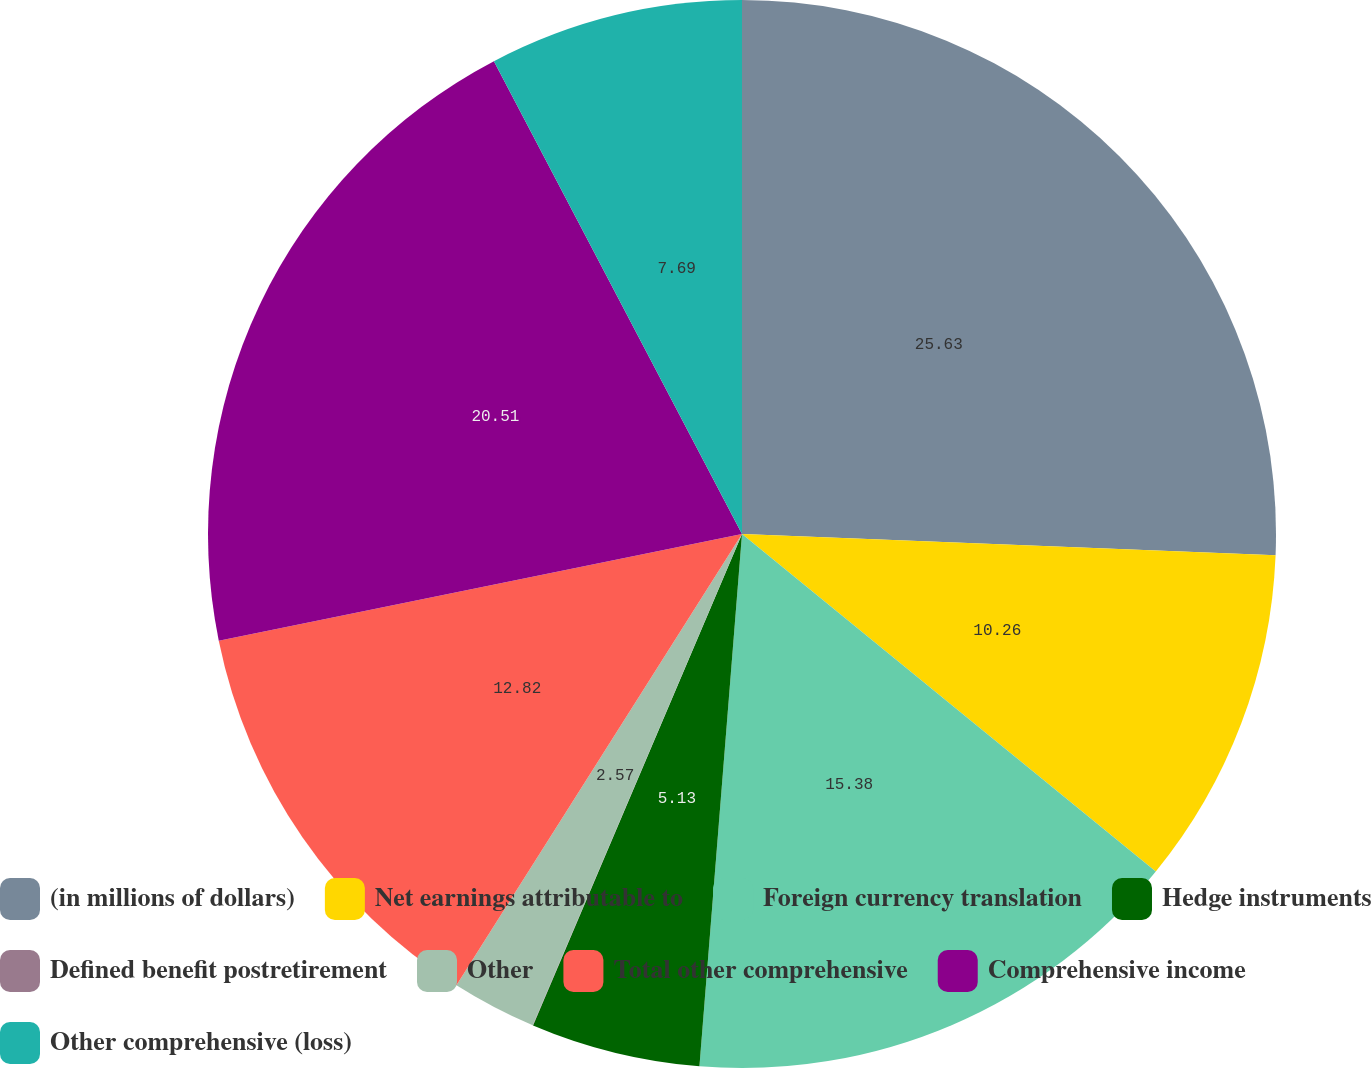Convert chart. <chart><loc_0><loc_0><loc_500><loc_500><pie_chart><fcel>(in millions of dollars)<fcel>Net earnings attributable to<fcel>Foreign currency translation<fcel>Hedge instruments<fcel>Defined benefit postretirement<fcel>Other<fcel>Total other comprehensive<fcel>Comprehensive income<fcel>Other comprehensive (loss)<nl><fcel>25.63%<fcel>10.26%<fcel>15.38%<fcel>5.13%<fcel>0.01%<fcel>2.57%<fcel>12.82%<fcel>20.51%<fcel>7.69%<nl></chart> 